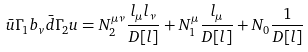<formula> <loc_0><loc_0><loc_500><loc_500>\bar { u } \Gamma _ { 1 } b _ { v } \bar { d } \Gamma _ { 2 } u = N _ { 2 } ^ { \mu \nu } \frac { l _ { \mu } l _ { \nu } } { D [ l ] } + N _ { 1 } ^ { \mu } \frac { l _ { \mu } } { D [ l ] } + N _ { 0 } \frac { 1 } { D [ l ] }</formula> 